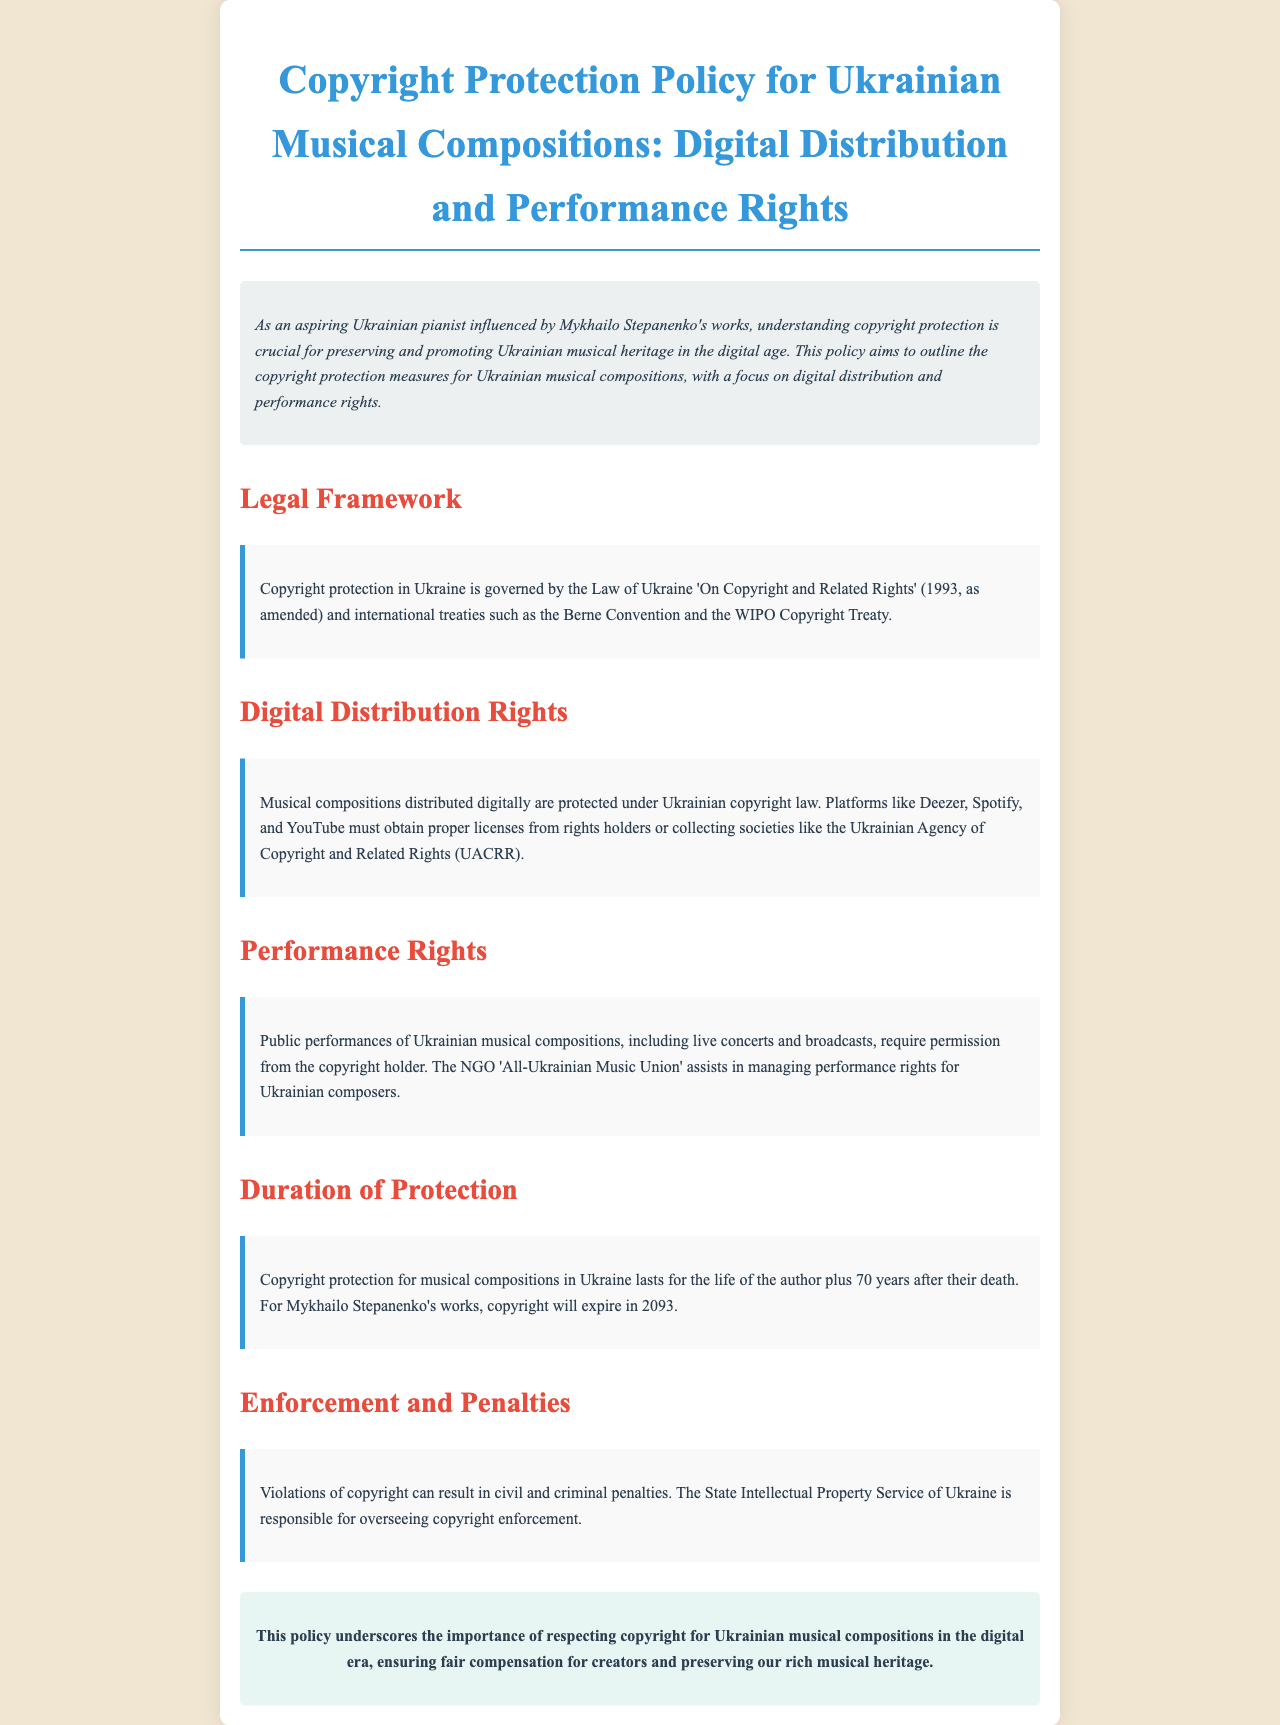What is the governing law for copyright protection in Ukraine? The document states that copyright protection in Ukraine is governed by the Law of Ukraine 'On Copyright and Related Rights' and international treaties.
Answer: Law of Ukraine 'On Copyright and Related Rights' What platforms need licenses for digital distribution of music? The text mentions that platforms like Deezer, Spotify, and YouTube must obtain licenses.
Answer: Deezer, Spotify, YouTube Who assists in managing performance rights for Ukrainian composers? The document identifies the NGO 'All-Ukrainian Music Union' as assisting in this area.
Answer: All-Ukrainian Music Union How long does copyright protection last for musical compositions in Ukraine? The document specifies the duration as the life of the author plus 70 years after their death.
Answer: Life of the author plus 70 years When will copyright for Mykhailo Stepanenko's works expire? According to the text, copyright for his works will expire in 2093.
Answer: 2093 What penalties can result from violating copyright? The document states that violations can result in civil and criminal penalties.
Answer: Civil and criminal penalties What is the purpose of the copyright protection policy? The document outlines that the policy aims to ensure fair compensation for creators and preserve the musical heritage.
Answer: Ensure fair compensation and preserve musical heritage 